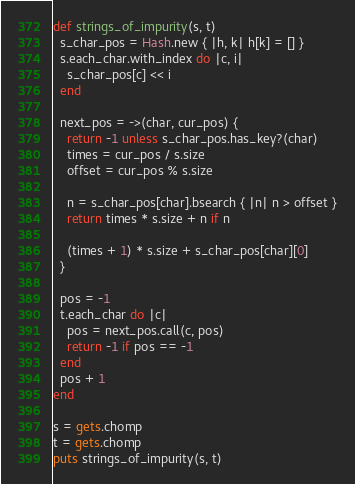Convert code to text. <code><loc_0><loc_0><loc_500><loc_500><_Ruby_>def strings_of_impurity(s, t)
  s_char_pos = Hash.new { |h, k| h[k] = [] }
  s.each_char.with_index do |c, i|
    s_char_pos[c] << i
  end

  next_pos = ->(char, cur_pos) {
    return -1 unless s_char_pos.has_key?(char)
    times = cur_pos / s.size
    offset = cur_pos % s.size

    n = s_char_pos[char].bsearch { |n| n > offset }
    return times * s.size + n if n

    (times + 1) * s.size + s_char_pos[char][0]
  }

  pos = -1
  t.each_char do |c|
    pos = next_pos.call(c, pos)
    return -1 if pos == -1
  end
  pos + 1
end

s = gets.chomp
t = gets.chomp
puts strings_of_impurity(s, t)</code> 